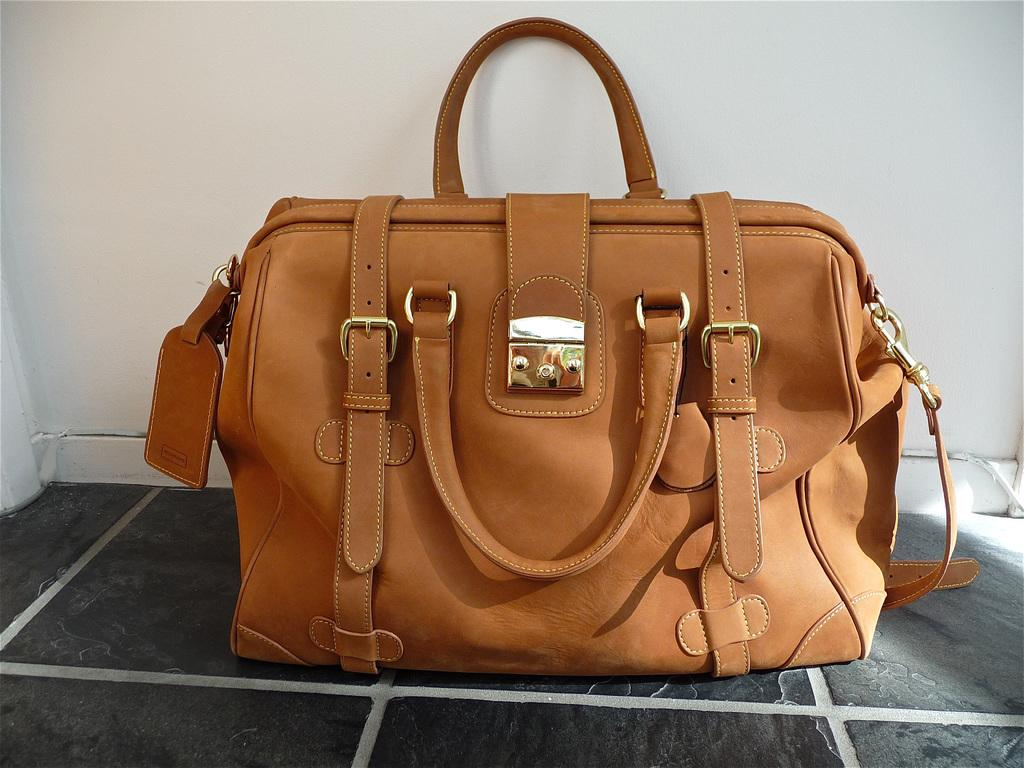What type of bag is visible in the image? There is a brown color bag in the image. What other items can be seen in the image besides the bag? There are belts in the image. What type of cap is worn by the quill in the image? There is no cap or quill present in the image; it only features a brown color bag and belts. 